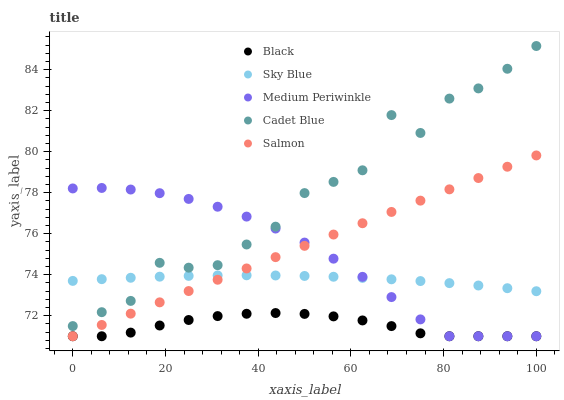Does Black have the minimum area under the curve?
Answer yes or no. Yes. Does Cadet Blue have the maximum area under the curve?
Answer yes or no. Yes. Does Cadet Blue have the minimum area under the curve?
Answer yes or no. No. Does Black have the maximum area under the curve?
Answer yes or no. No. Is Salmon the smoothest?
Answer yes or no. Yes. Is Cadet Blue the roughest?
Answer yes or no. Yes. Is Black the smoothest?
Answer yes or no. No. Is Black the roughest?
Answer yes or no. No. Does Black have the lowest value?
Answer yes or no. Yes. Does Cadet Blue have the lowest value?
Answer yes or no. No. Does Cadet Blue have the highest value?
Answer yes or no. Yes. Does Black have the highest value?
Answer yes or no. No. Is Salmon less than Cadet Blue?
Answer yes or no. Yes. Is Cadet Blue greater than Salmon?
Answer yes or no. Yes. Does Salmon intersect Sky Blue?
Answer yes or no. Yes. Is Salmon less than Sky Blue?
Answer yes or no. No. Is Salmon greater than Sky Blue?
Answer yes or no. No. Does Salmon intersect Cadet Blue?
Answer yes or no. No. 